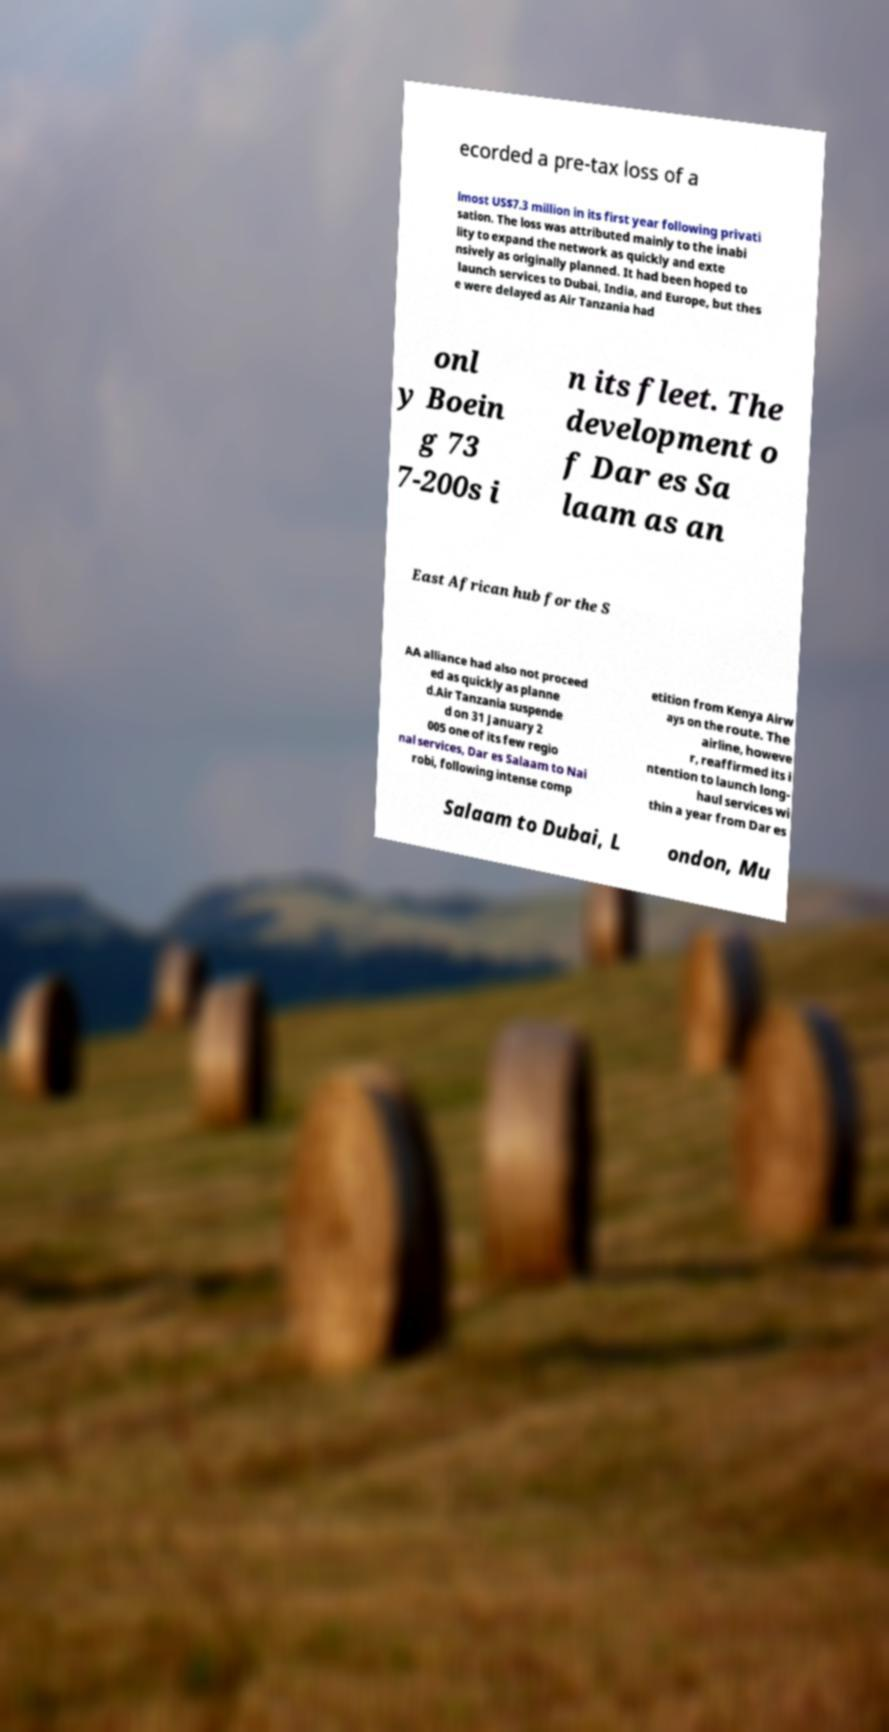What messages or text are displayed in this image? I need them in a readable, typed format. ecorded a pre-tax loss of a lmost US$7.3 million in its first year following privati sation. The loss was attributed mainly to the inabi lity to expand the network as quickly and exte nsively as originally planned. It had been hoped to launch services to Dubai, India, and Europe, but thes e were delayed as Air Tanzania had onl y Boein g 73 7-200s i n its fleet. The development o f Dar es Sa laam as an East African hub for the S AA alliance had also not proceed ed as quickly as planne d.Air Tanzania suspende d on 31 January 2 005 one of its few regio nal services, Dar es Salaam to Nai robi, following intense comp etition from Kenya Airw ays on the route. The airline, howeve r, reaffirmed its i ntention to launch long- haul services wi thin a year from Dar es Salaam to Dubai, L ondon, Mu 